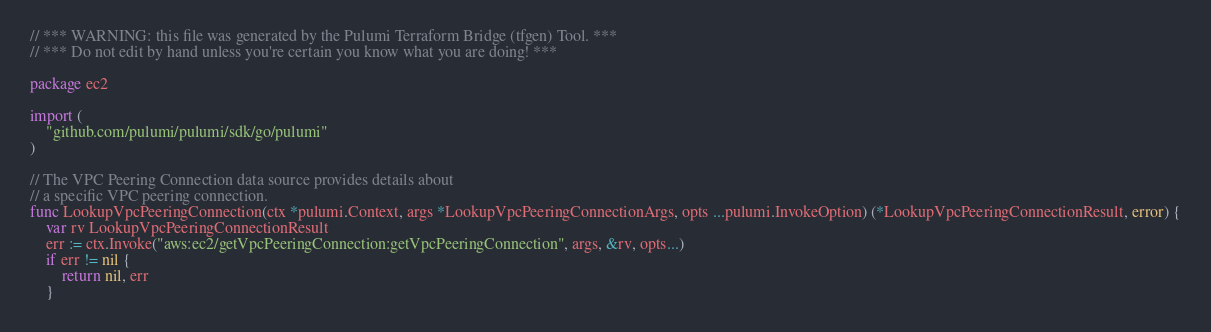Convert code to text. <code><loc_0><loc_0><loc_500><loc_500><_Go_>// *** WARNING: this file was generated by the Pulumi Terraform Bridge (tfgen) Tool. ***
// *** Do not edit by hand unless you're certain you know what you are doing! ***

package ec2

import (
	"github.com/pulumi/pulumi/sdk/go/pulumi"
)

// The VPC Peering Connection data source provides details about
// a specific VPC peering connection.
func LookupVpcPeeringConnection(ctx *pulumi.Context, args *LookupVpcPeeringConnectionArgs, opts ...pulumi.InvokeOption) (*LookupVpcPeeringConnectionResult, error) {
	var rv LookupVpcPeeringConnectionResult
	err := ctx.Invoke("aws:ec2/getVpcPeeringConnection:getVpcPeeringConnection", args, &rv, opts...)
	if err != nil {
		return nil, err
	}</code> 